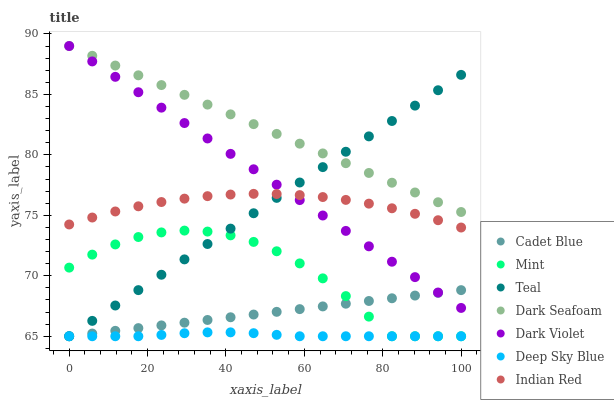Does Deep Sky Blue have the minimum area under the curve?
Answer yes or no. Yes. Does Dark Seafoam have the maximum area under the curve?
Answer yes or no. Yes. Does Teal have the minimum area under the curve?
Answer yes or no. No. Does Teal have the maximum area under the curve?
Answer yes or no. No. Is Dark Violet the smoothest?
Answer yes or no. Yes. Is Mint the roughest?
Answer yes or no. Yes. Is Teal the smoothest?
Answer yes or no. No. Is Teal the roughest?
Answer yes or no. No. Does Cadet Blue have the lowest value?
Answer yes or no. Yes. Does Dark Violet have the lowest value?
Answer yes or no. No. Does Dark Seafoam have the highest value?
Answer yes or no. Yes. Does Teal have the highest value?
Answer yes or no. No. Is Mint less than Indian Red?
Answer yes or no. Yes. Is Dark Seafoam greater than Cadet Blue?
Answer yes or no. Yes. Does Dark Seafoam intersect Teal?
Answer yes or no. Yes. Is Dark Seafoam less than Teal?
Answer yes or no. No. Is Dark Seafoam greater than Teal?
Answer yes or no. No. Does Mint intersect Indian Red?
Answer yes or no. No. 